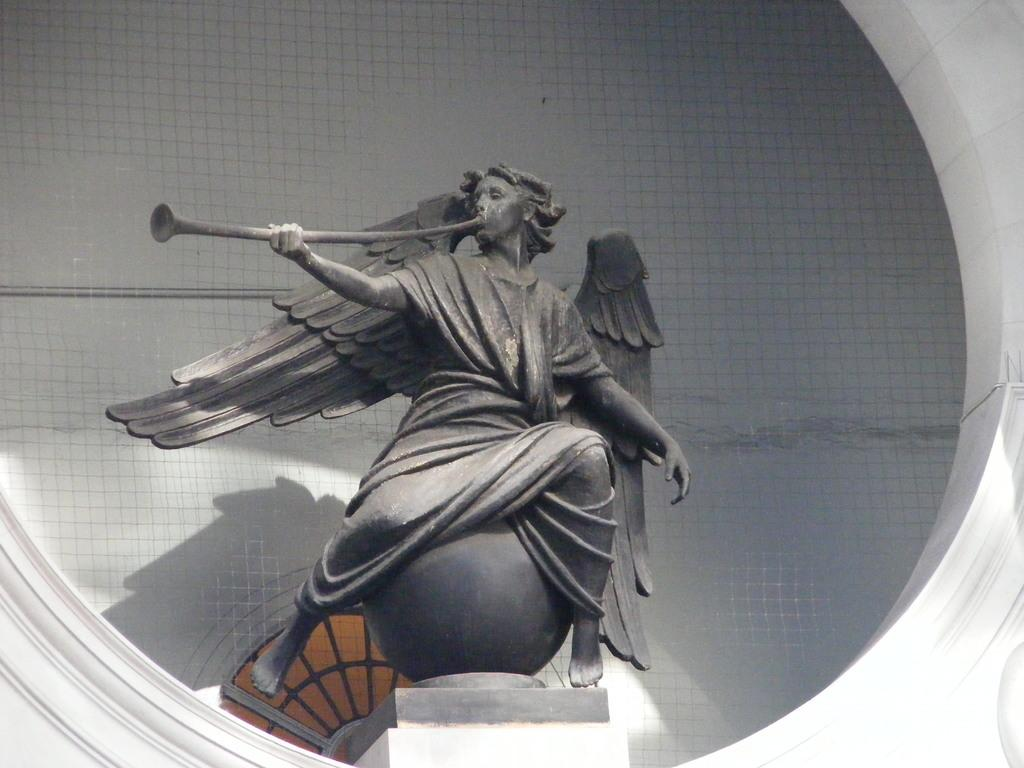What is the main subject of the image? There is a statue in the image. What is the statue holding in its hand? The statue is holding something in its hand. What is the statue sitting on? The statue is sitting on a round structure. What can be seen in the background of the image? There is a wall in the background of the image. What type of orange is present in the image? There is no orange present in the image. 